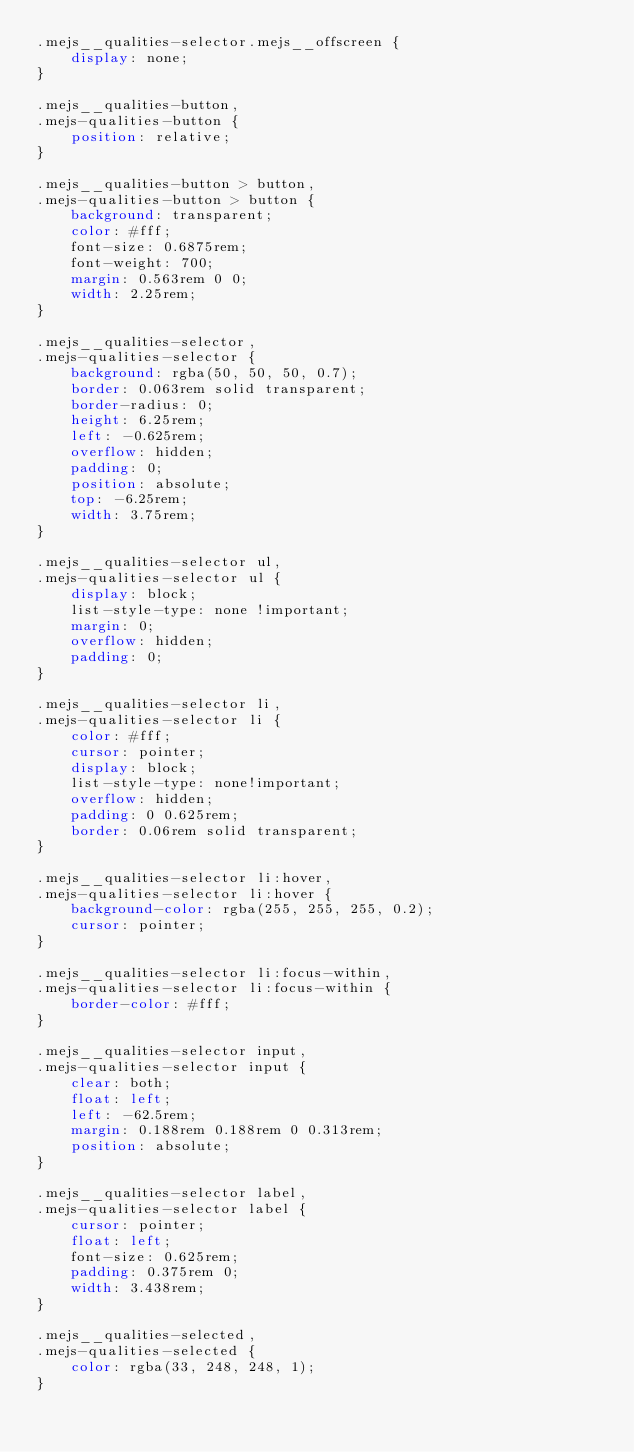Convert code to text. <code><loc_0><loc_0><loc_500><loc_500><_CSS_>.mejs__qualities-selector.mejs__offscreen {
    display: none;
}

.mejs__qualities-button,
.mejs-qualities-button {
    position: relative;
}

.mejs__qualities-button > button,
.mejs-qualities-button > button {
    background: transparent;
    color: #fff;
    font-size: 0.6875rem;
    font-weight: 700;
    margin: 0.563rem 0 0;
    width: 2.25rem;
}

.mejs__qualities-selector,
.mejs-qualities-selector {
    background: rgba(50, 50, 50, 0.7);
    border: 0.063rem solid transparent;
    border-radius: 0;
    height: 6.25rem;
    left: -0.625rem;
    overflow: hidden;
    padding: 0;
    position: absolute;
    top: -6.25rem;
    width: 3.75rem;
}

.mejs__qualities-selector ul,
.mejs-qualities-selector ul {
    display: block;
    list-style-type: none !important;
    margin: 0;
    overflow: hidden;
    padding: 0;
}

.mejs__qualities-selector li,
.mejs-qualities-selector li {
    color: #fff;
    cursor: pointer;
    display: block;
    list-style-type: none!important;
    overflow: hidden;
    padding: 0 0.625rem;
    border: 0.06rem solid transparent;
}

.mejs__qualities-selector li:hover,
.mejs-qualities-selector li:hover {
    background-color: rgba(255, 255, 255, 0.2);
    cursor: pointer;
}

.mejs__qualities-selector li:focus-within,
.mejs-qualities-selector li:focus-within {
    border-color: #fff;
}

.mejs__qualities-selector input,
.mejs-qualities-selector input {
    clear: both;
    float: left;
    left: -62.5rem;
    margin: 0.188rem 0.188rem 0 0.313rem;
    position: absolute;
}

.mejs__qualities-selector label,
.mejs-qualities-selector label {
    cursor: pointer;
    float: left;
    font-size: 0.625rem;
    padding: 0.375rem 0;
    width: 3.438rem;
}

.mejs__qualities-selected,
.mejs-qualities-selected {
    color: rgba(33, 248, 248, 1);
}
</code> 